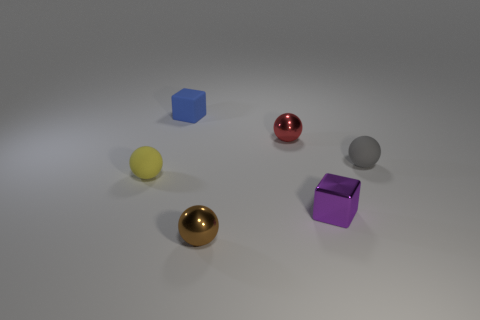Add 2 blue cubes. How many objects exist? 8 Subtract all cubes. How many objects are left? 4 Subtract 0 red cylinders. How many objects are left? 6 Subtract all yellow rubber objects. Subtract all small matte balls. How many objects are left? 3 Add 2 metal cubes. How many metal cubes are left? 3 Add 5 cyan metallic cubes. How many cyan metallic cubes exist? 5 